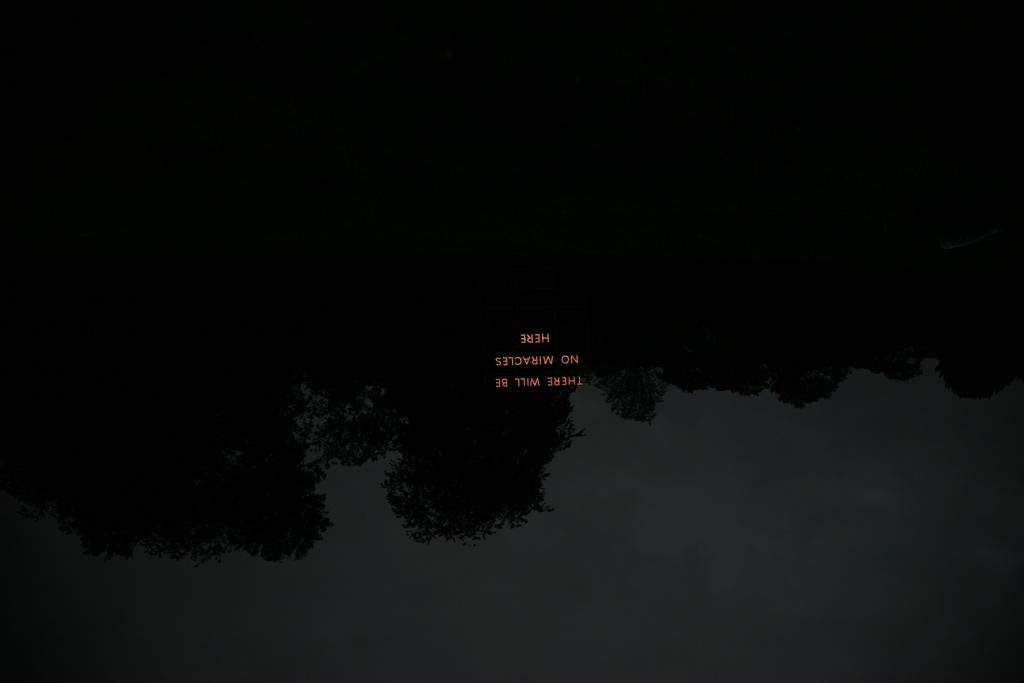What type of vegetation can be seen in the image? There are trees in the image. What part of the natural environment is visible in the image? The sky is visible in the image. Is there any text present in the image? Yes, there is text written on the image. How many fish can be seen swimming in the image? There are no fish present in the image. What type of sweater is the person wearing in the image? There is no person or sweater present in the image. 